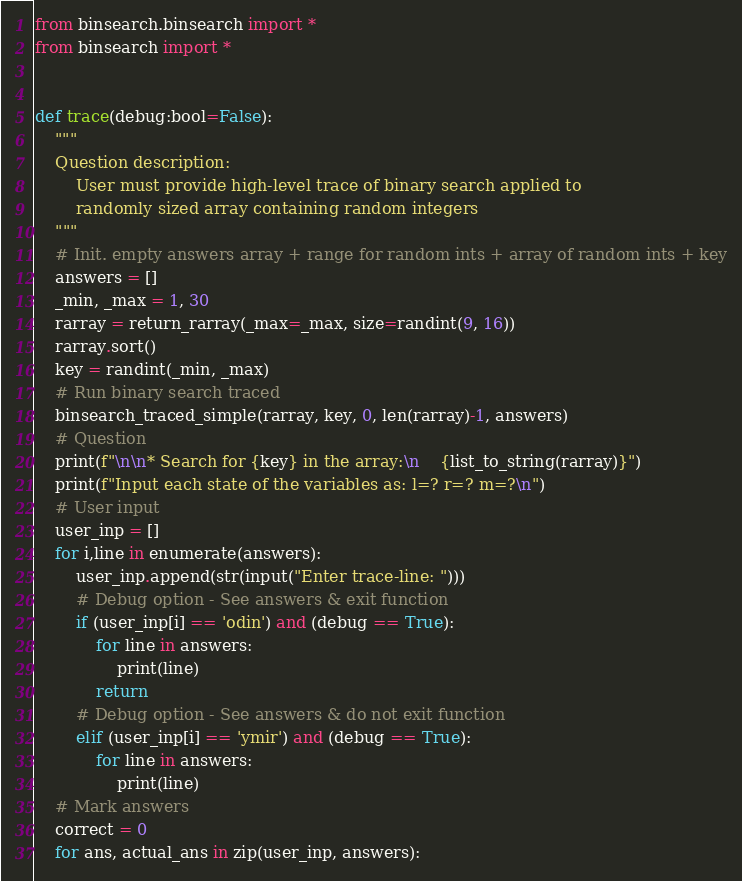Convert code to text. <code><loc_0><loc_0><loc_500><loc_500><_Python_>from binsearch.binsearch import *
from binsearch import *


def trace(debug:bool=False):
    """
    Question description:
        User must provide high-level trace of binary search applied to
        randomly sized array containing random integers
    """
    # Init. empty answers array + range for random ints + array of random ints + key
    answers = []
    _min, _max = 1, 30
    rarray = return_rarray(_max=_max, size=randint(9, 16))
    rarray.sort()
    key = randint(_min, _max)
    # Run binary search traced
    binsearch_traced_simple(rarray, key, 0, len(rarray)-1, answers)
    # Question
    print(f"\n\n* Search for {key} in the array:\n    {list_to_string(rarray)}")
    print(f"Input each state of the variables as: l=? r=? m=?\n")
    # User input
    user_inp = []
    for i,line in enumerate(answers):
        user_inp.append(str(input("Enter trace-line: ")))
        # Debug option - See answers & exit function
        if (user_inp[i] == 'odin') and (debug == True):
            for line in answers:
                print(line)
            return
        # Debug option - See answers & do not exit function
        elif (user_inp[i] == 'ymir') and (debug == True):
            for line in answers:
                print(line)
    # Mark answers
    correct = 0
    for ans, actual_ans in zip(user_inp, answers):</code> 